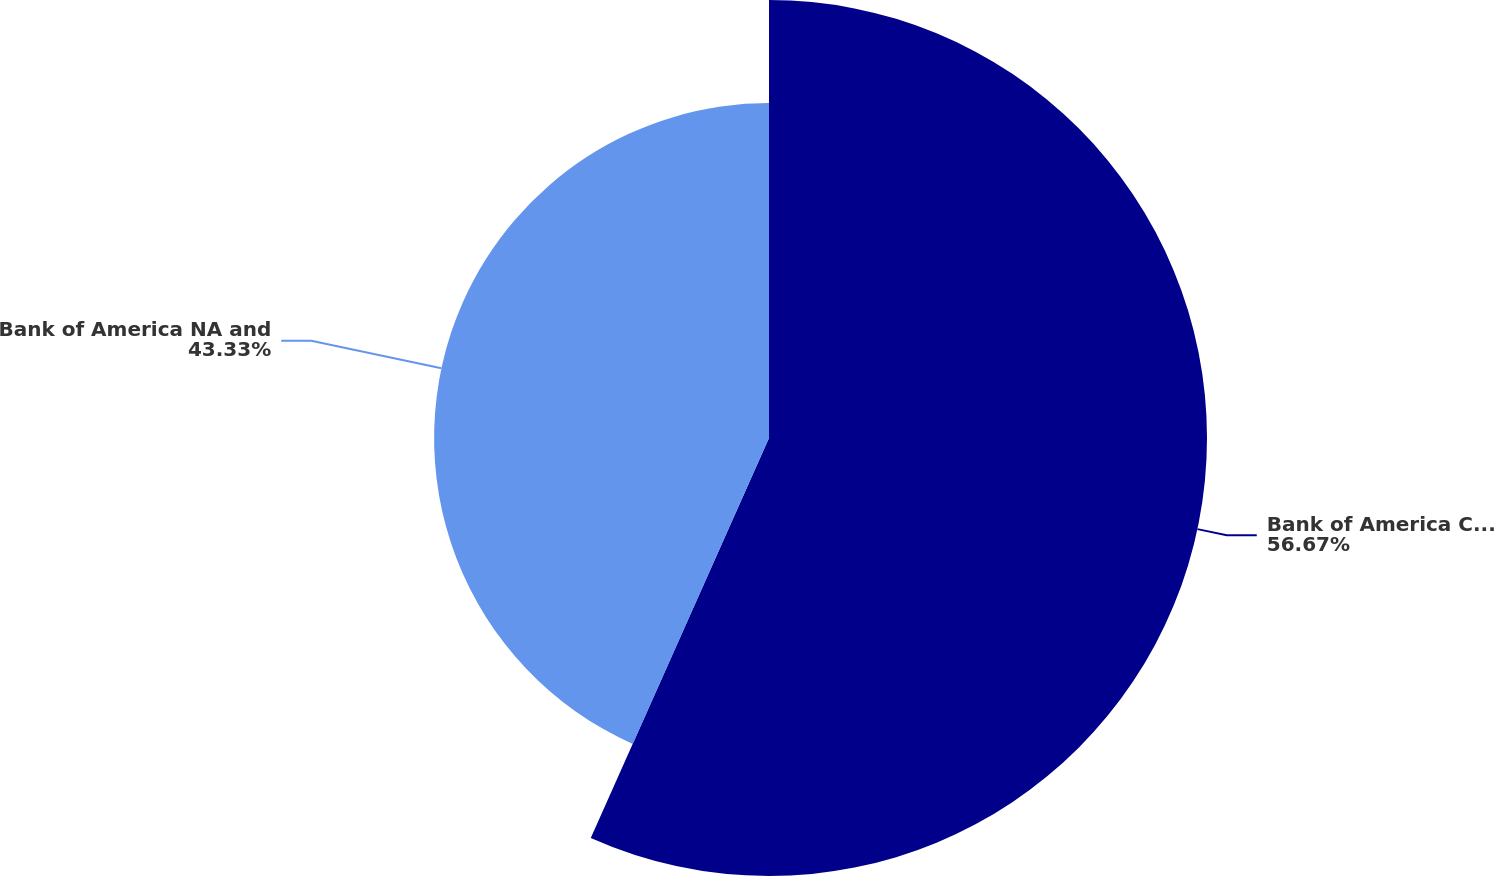<chart> <loc_0><loc_0><loc_500><loc_500><pie_chart><fcel>Bank of America Corporation<fcel>Bank of America NA and<nl><fcel>56.67%<fcel>43.33%<nl></chart> 